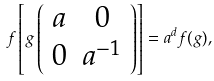<formula> <loc_0><loc_0><loc_500><loc_500>f \left [ g \left ( \begin{array} { c c } a & 0 \\ 0 & a ^ { - 1 } \end{array} \right ) \right ] = a ^ { d } f ( g ) ,</formula> 